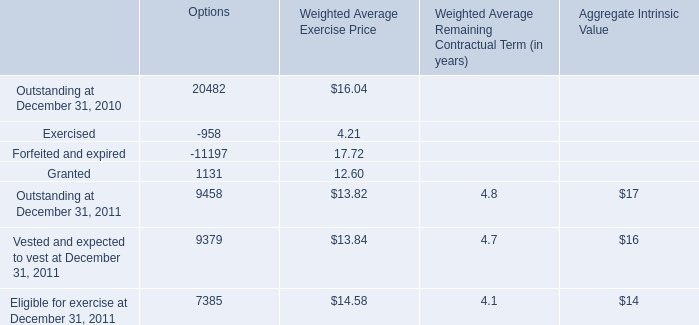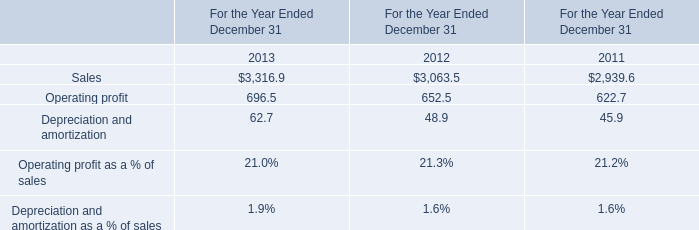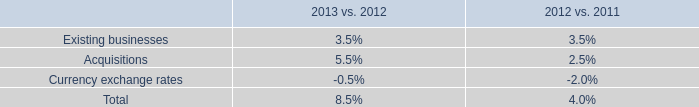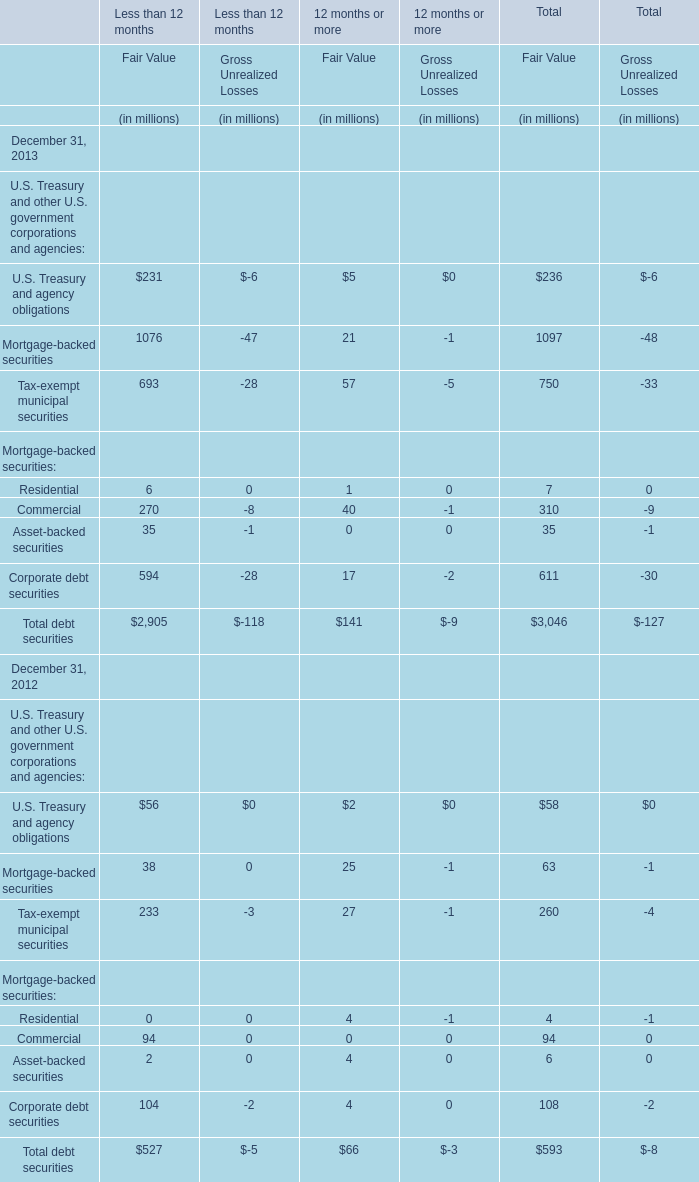Does the value of U.S. Treasury and agency obligations for Fair Value of Less than 12 months in 2012 greater than that in 2013 ? 
Answer: No. 